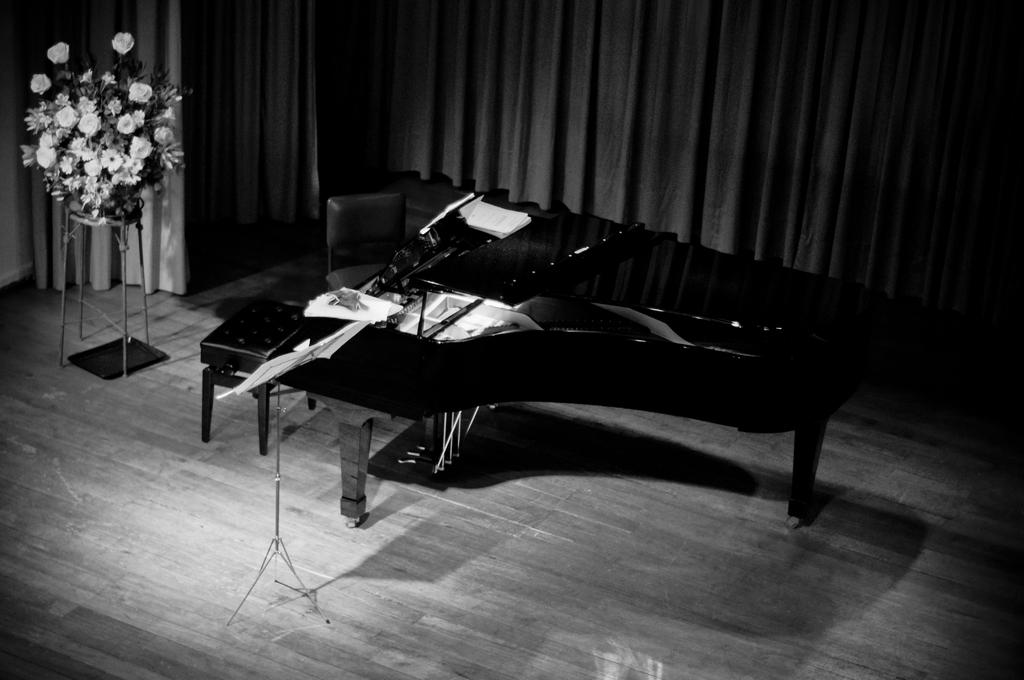What is the color scheme of the image? The image is black and white. What type of object can be seen hanging in the image? There is a curtain in the image. What musical instrument is visible in the image? There is a piano keyboard in the image. What type of furniture is in front of the piano keyboard? There is a chair in front of the piano keyboard. What type of plant is present in the image? There is a plant on a stand in the image. What type of rice is being advertised on the canvas in the image? There is no rice or canvas present in the image; it features a curtain, piano keyboard, chair, and plant on a stand. 